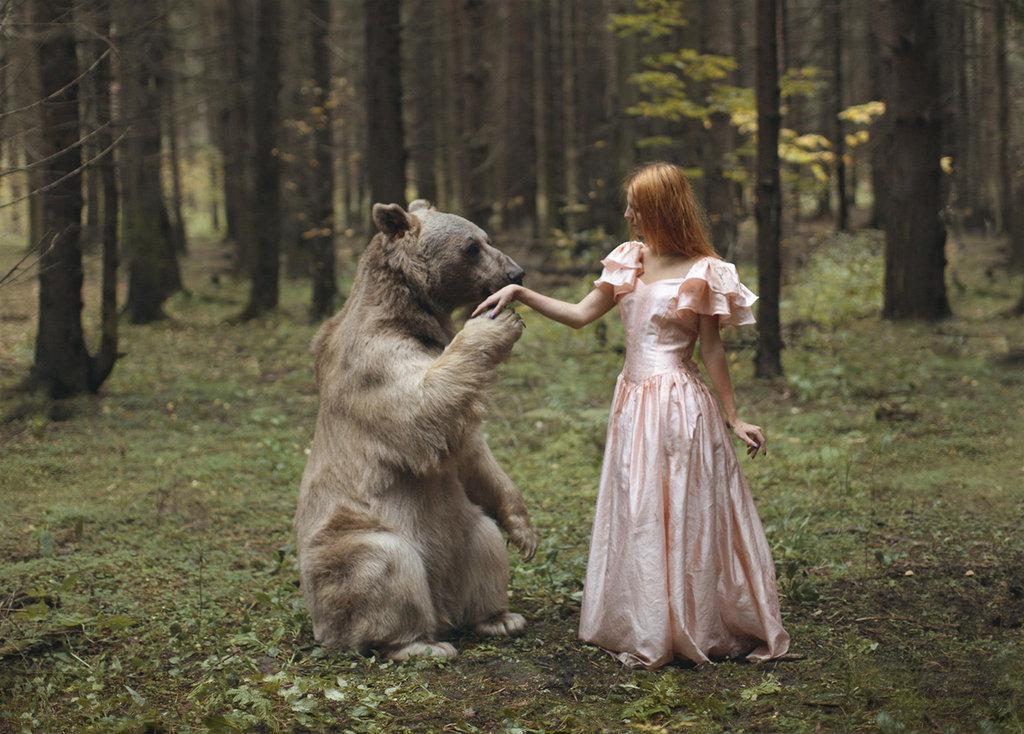Can you describe this image briefly? In this picture we can see a woman and a bear are on the path and behind the women there are trees and grass. 